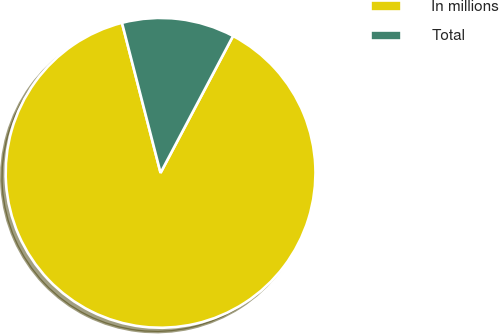<chart> <loc_0><loc_0><loc_500><loc_500><pie_chart><fcel>In millions<fcel>Total<nl><fcel>88.24%<fcel>11.76%<nl></chart> 